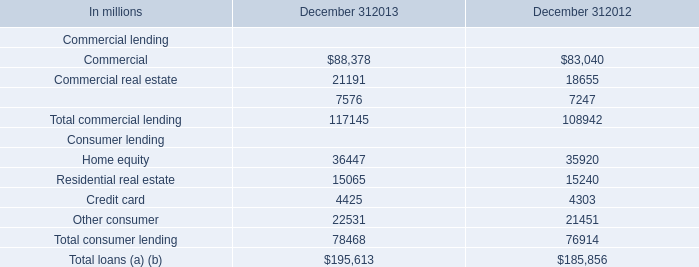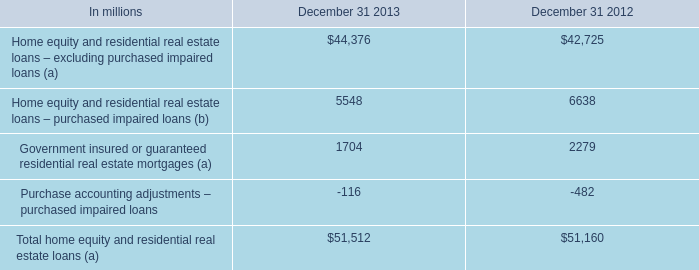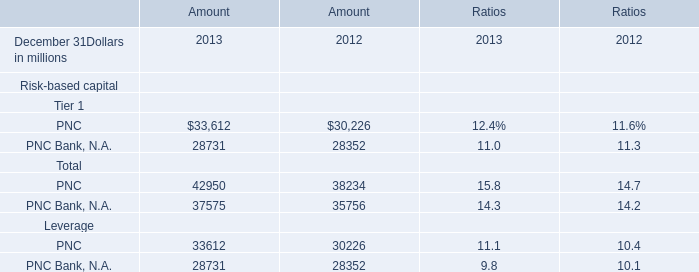What is the sum of Commercial of December 312012, PNC Bank, N.A. of Amount 2012, and Total consumer lending Consumer lending of December 312012 ? 
Computations: ((83040.0 + 28352.0) + 76914.0)
Answer: 188306.0. 